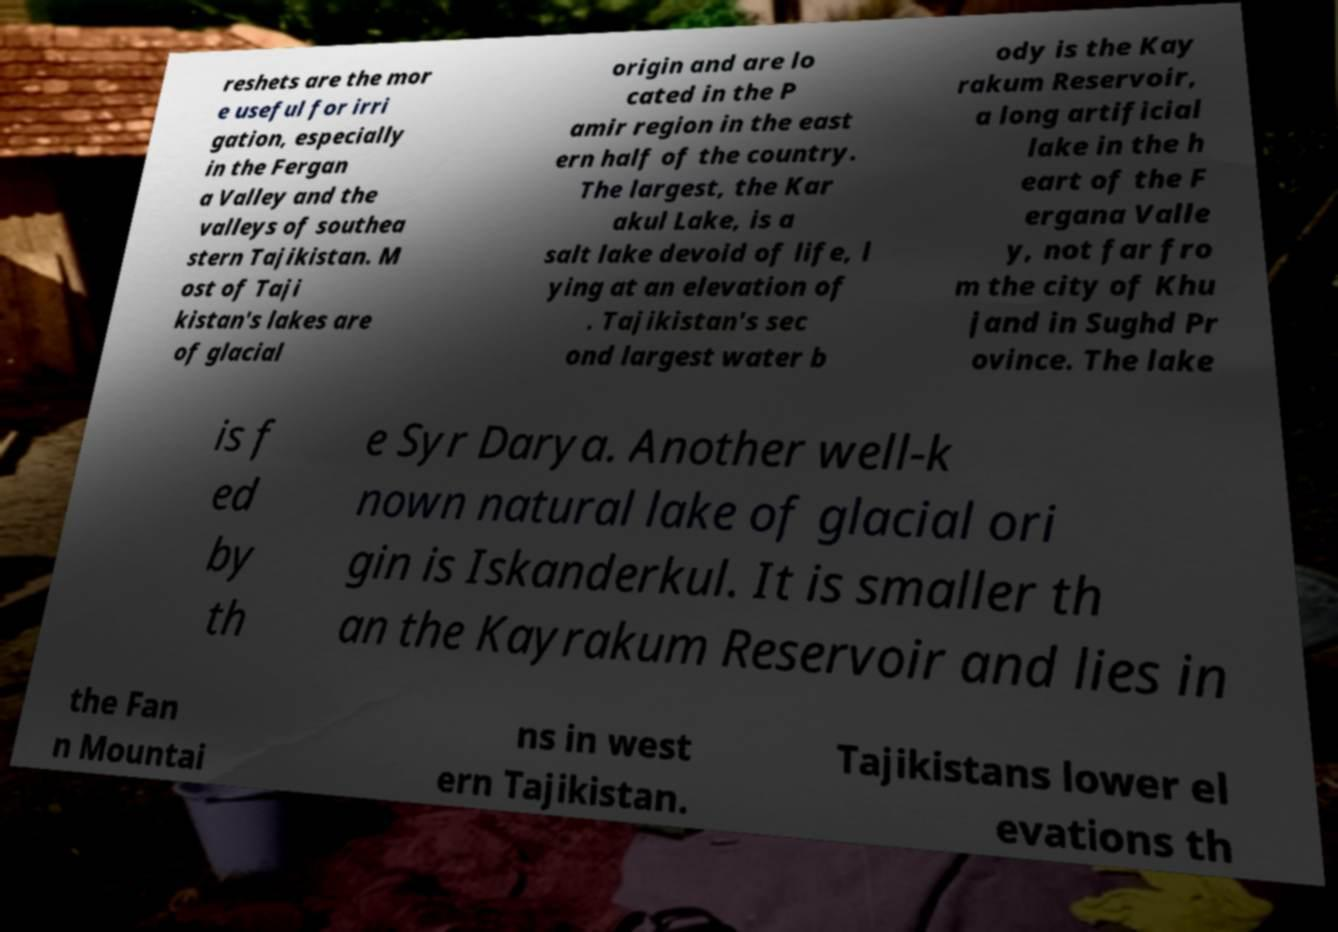There's text embedded in this image that I need extracted. Can you transcribe it verbatim? reshets are the mor e useful for irri gation, especially in the Fergan a Valley and the valleys of southea stern Tajikistan. M ost of Taji kistan's lakes are of glacial origin and are lo cated in the P amir region in the east ern half of the country. The largest, the Kar akul Lake, is a salt lake devoid of life, l ying at an elevation of . Tajikistan's sec ond largest water b ody is the Kay rakum Reservoir, a long artificial lake in the h eart of the F ergana Valle y, not far fro m the city of Khu jand in Sughd Pr ovince. The lake is f ed by th e Syr Darya. Another well-k nown natural lake of glacial ori gin is Iskanderkul. It is smaller th an the Kayrakum Reservoir and lies in the Fan n Mountai ns in west ern Tajikistan. Tajikistans lower el evations th 